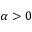Convert formula to latex. <formula><loc_0><loc_0><loc_500><loc_500>\alpha > 0</formula> 